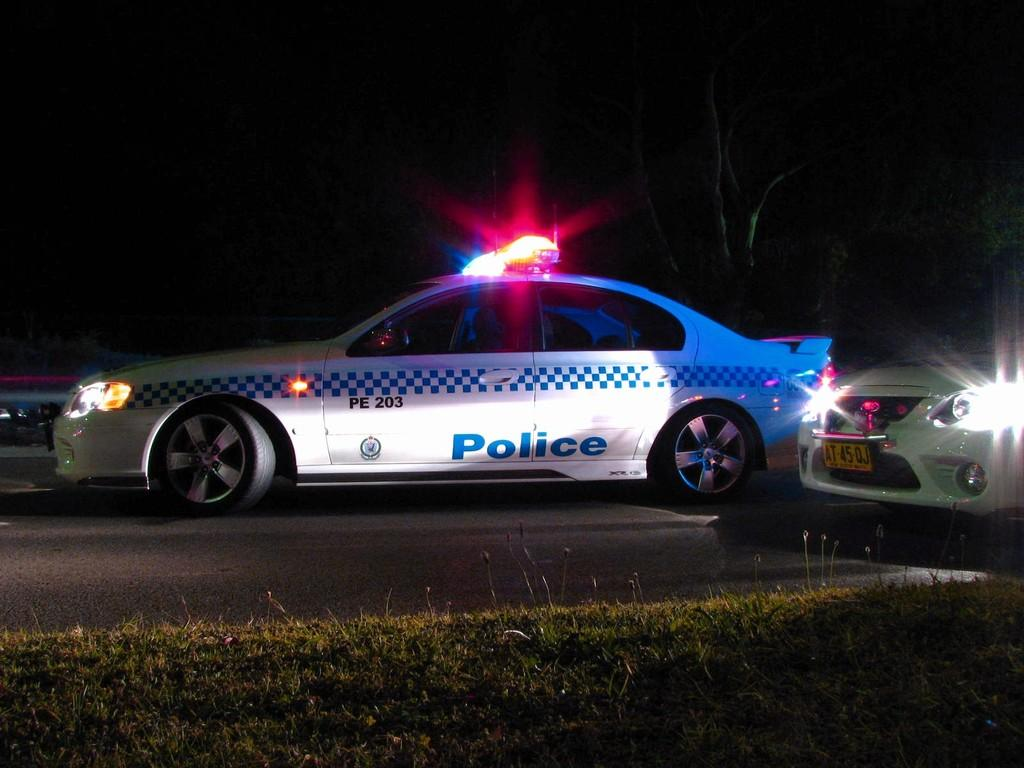What is the main subject of the image? The main subject of the image is cars on the road. Can you describe the environment in the image? There is grass visible at the bottom of the image, and trees are in the background. What is the price of the event happening in the image? There is no event happening in the image, so there is no price to be determined. 